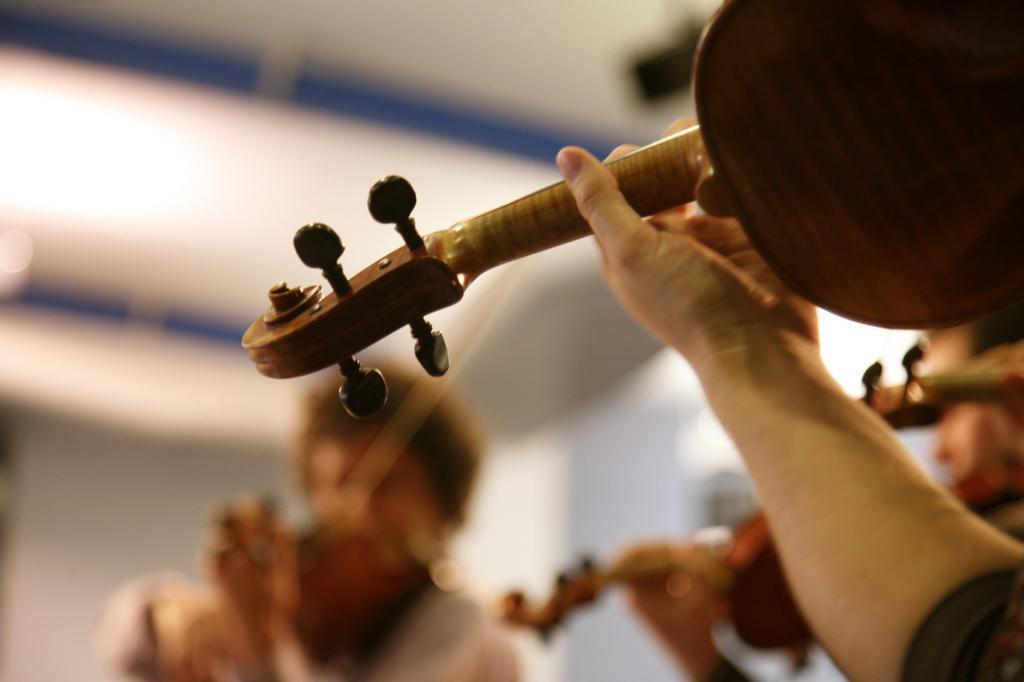Can you describe this image briefly? In this image in the foreground there is one person who is holding a violin and playing, and in the background there are two persons who are holding violin and playing and there is a wall and the background is blurred. 